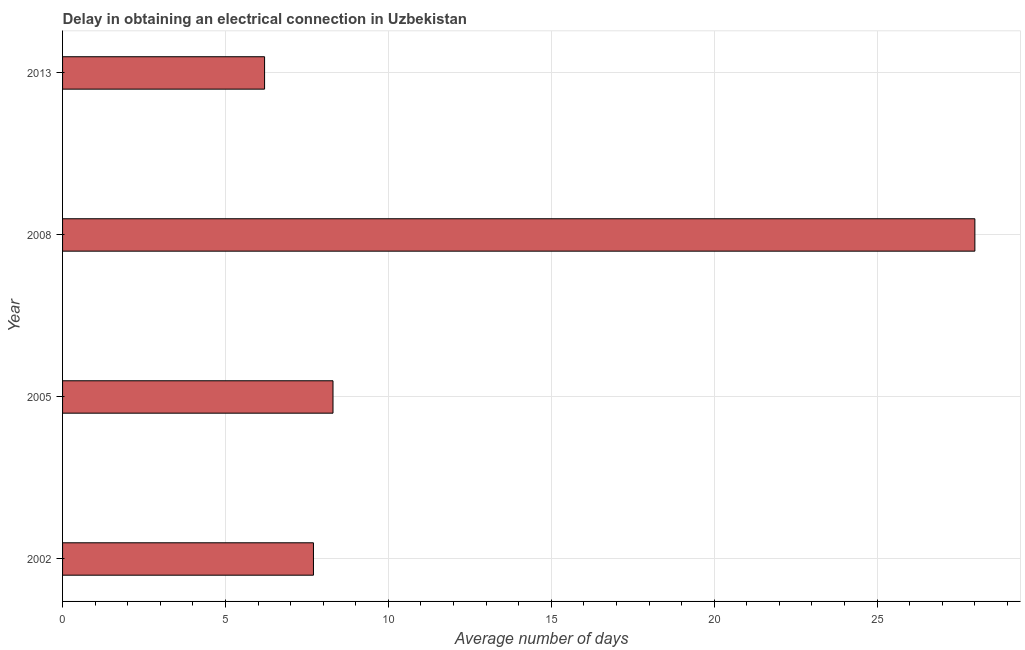Does the graph contain any zero values?
Your answer should be very brief. No. Does the graph contain grids?
Your response must be concise. Yes. What is the title of the graph?
Provide a succinct answer. Delay in obtaining an electrical connection in Uzbekistan. What is the label or title of the X-axis?
Offer a terse response. Average number of days. What is the label or title of the Y-axis?
Provide a succinct answer. Year. What is the dalay in electrical connection in 2005?
Offer a terse response. 8.3. Across all years, what is the maximum dalay in electrical connection?
Keep it short and to the point. 28. In which year was the dalay in electrical connection minimum?
Ensure brevity in your answer.  2013. What is the sum of the dalay in electrical connection?
Make the answer very short. 50.2. What is the difference between the dalay in electrical connection in 2002 and 2005?
Provide a short and direct response. -0.6. What is the average dalay in electrical connection per year?
Offer a terse response. 12.55. What is the ratio of the dalay in electrical connection in 2005 to that in 2013?
Your answer should be compact. 1.34. Is the difference between the dalay in electrical connection in 2002 and 2005 greater than the difference between any two years?
Offer a terse response. No. What is the difference between the highest and the second highest dalay in electrical connection?
Your answer should be very brief. 19.7. Is the sum of the dalay in electrical connection in 2002 and 2005 greater than the maximum dalay in electrical connection across all years?
Your response must be concise. No. What is the difference between the highest and the lowest dalay in electrical connection?
Ensure brevity in your answer.  21.8. What is the difference between two consecutive major ticks on the X-axis?
Your response must be concise. 5. Are the values on the major ticks of X-axis written in scientific E-notation?
Your answer should be compact. No. What is the Average number of days of 2002?
Your answer should be compact. 7.7. What is the Average number of days of 2005?
Ensure brevity in your answer.  8.3. What is the difference between the Average number of days in 2002 and 2005?
Make the answer very short. -0.6. What is the difference between the Average number of days in 2002 and 2008?
Keep it short and to the point. -20.3. What is the difference between the Average number of days in 2005 and 2008?
Provide a succinct answer. -19.7. What is the difference between the Average number of days in 2005 and 2013?
Provide a succinct answer. 2.1. What is the difference between the Average number of days in 2008 and 2013?
Provide a succinct answer. 21.8. What is the ratio of the Average number of days in 2002 to that in 2005?
Your response must be concise. 0.93. What is the ratio of the Average number of days in 2002 to that in 2008?
Keep it short and to the point. 0.28. What is the ratio of the Average number of days in 2002 to that in 2013?
Offer a very short reply. 1.24. What is the ratio of the Average number of days in 2005 to that in 2008?
Your response must be concise. 0.3. What is the ratio of the Average number of days in 2005 to that in 2013?
Keep it short and to the point. 1.34. What is the ratio of the Average number of days in 2008 to that in 2013?
Give a very brief answer. 4.52. 